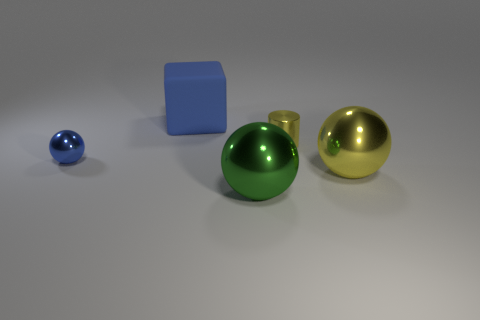Add 3 cyan metal cylinders. How many objects exist? 8 Subtract all blocks. How many objects are left? 4 Subtract 0 yellow blocks. How many objects are left? 5 Subtract all rubber things. Subtract all large blue balls. How many objects are left? 4 Add 1 small blue metal spheres. How many small blue metal spheres are left? 2 Add 3 metallic things. How many metallic things exist? 7 